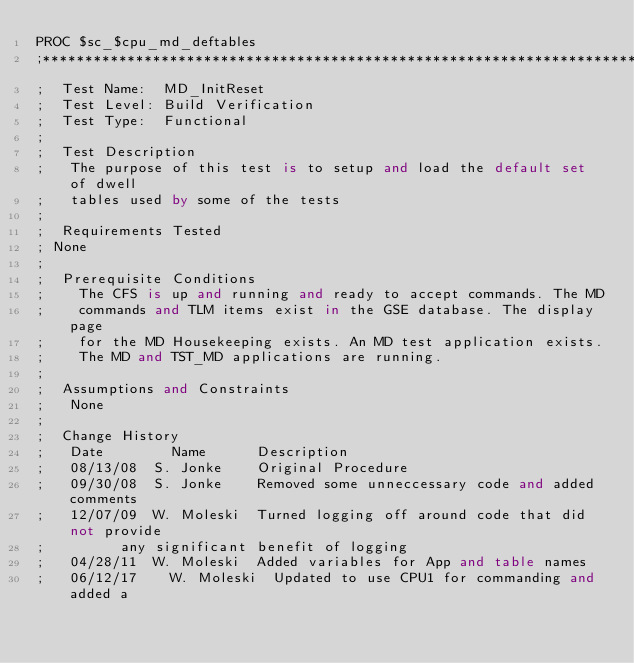Convert code to text. <code><loc_0><loc_0><loc_500><loc_500><_SQL_>PROC $sc_$cpu_md_deftables
;*******************************************************************************
;  Test Name:  MD_InitReset
;  Test Level: Build Verification 
;  Test Type:  Functional
;            
;  Test Description
;   The purpose of this test is to setup and load the default set of dwell
;   tables used by some of the tests
;
;  Requirements Tested
;	None
;
;  Prerequisite Conditions
;    The CFS is up and running and ready to accept commands. The MD
;    commands and TLM items exist in the GSE database. The display page
;    for the MD Housekeeping exists. An MD test application exists.
;    The MD and TST_MD applications are running.
;
;  Assumptions and Constraints
;   None
;
;  Change History
;   Date        Name	    Description
;   08/13/08	S. Jonke    Original Procedure
;   09/30/08	S. Jonke    Removed some unneccessary code and added comments
;   12/07/09	W. Moleski  Turned logging off around code that did not provide
;			    any significant benefit of logging
;   04/28/11	W. Moleski  Added variables for App and table names
;   06/12/17    W. Moleski  Updated to use CPU1 for commanding and added a</code> 